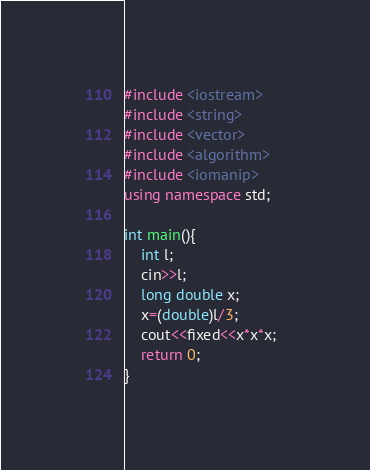<code> <loc_0><loc_0><loc_500><loc_500><_C++_>#include <iostream>
#include <string>
#include <vector>
#include <algorithm>
#include <iomanip>
using namespace std;

int main(){
    int l;
    cin>>l;
    long double x;
    x=(double)l/3;
    cout<<fixed<<x*x*x;  
    return 0;
}</code> 